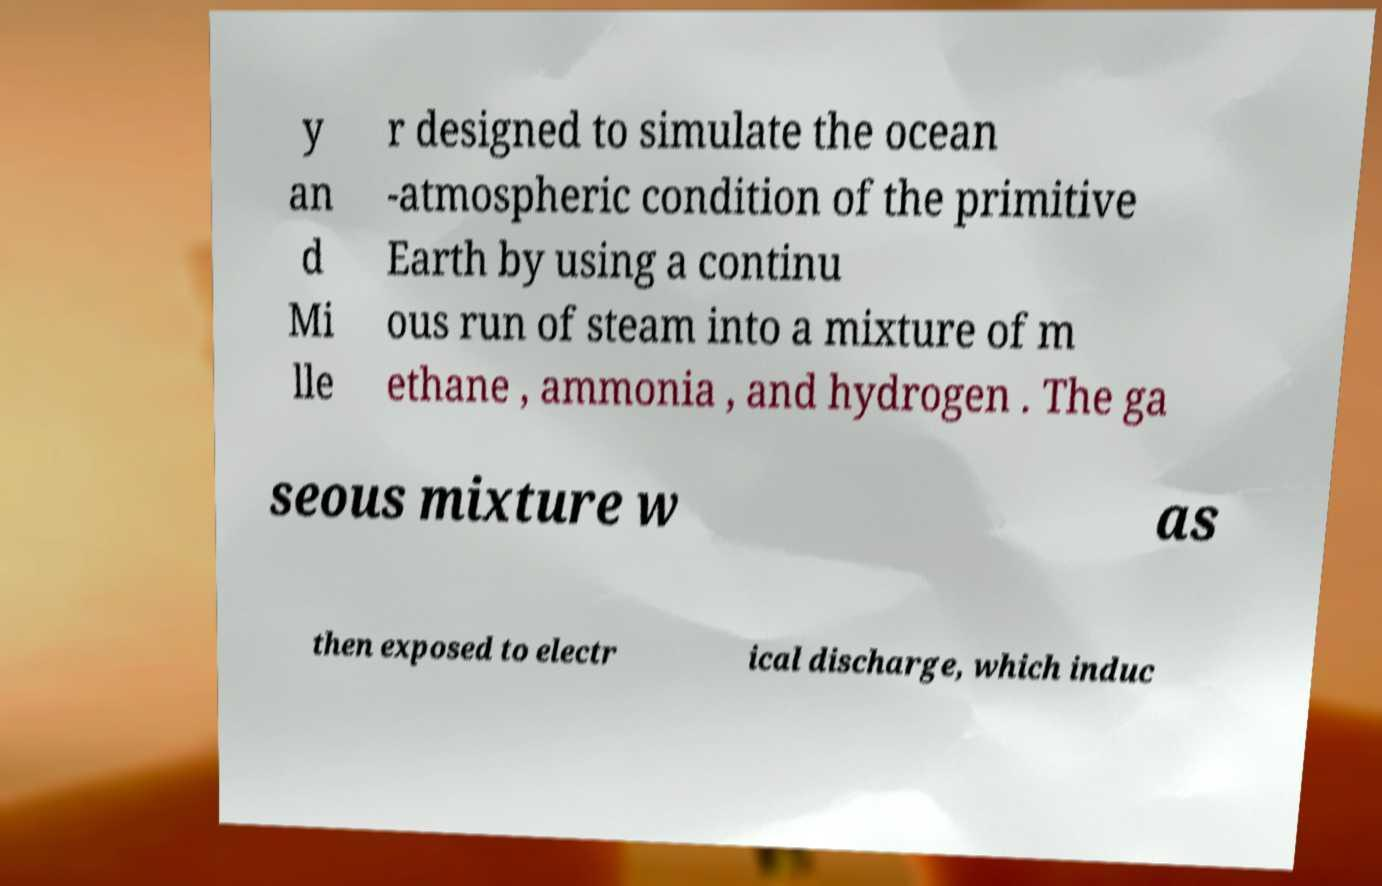I need the written content from this picture converted into text. Can you do that? y an d Mi lle r designed to simulate the ocean -atmospheric condition of the primitive Earth by using a continu ous run of steam into a mixture of m ethane , ammonia , and hydrogen . The ga seous mixture w as then exposed to electr ical discharge, which induc 